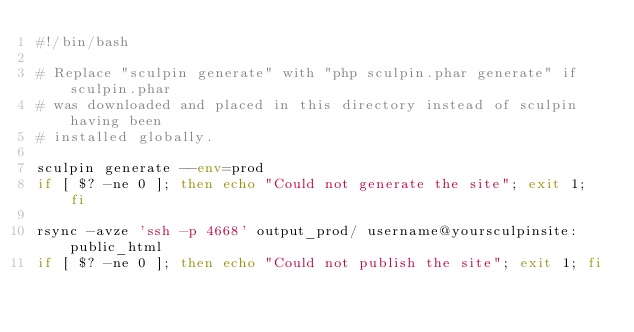<code> <loc_0><loc_0><loc_500><loc_500><_Bash_>#!/bin/bash

# Replace "sculpin generate" with "php sculpin.phar generate" if sculpin.phar
# was downloaded and placed in this directory instead of sculpin having been
# installed globally.

sculpin generate --env=prod
if [ $? -ne 0 ]; then echo "Could not generate the site"; exit 1; fi

rsync -avze 'ssh -p 4668' output_prod/ username@yoursculpinsite:public_html
if [ $? -ne 0 ]; then echo "Could not publish the site"; exit 1; fi
</code> 